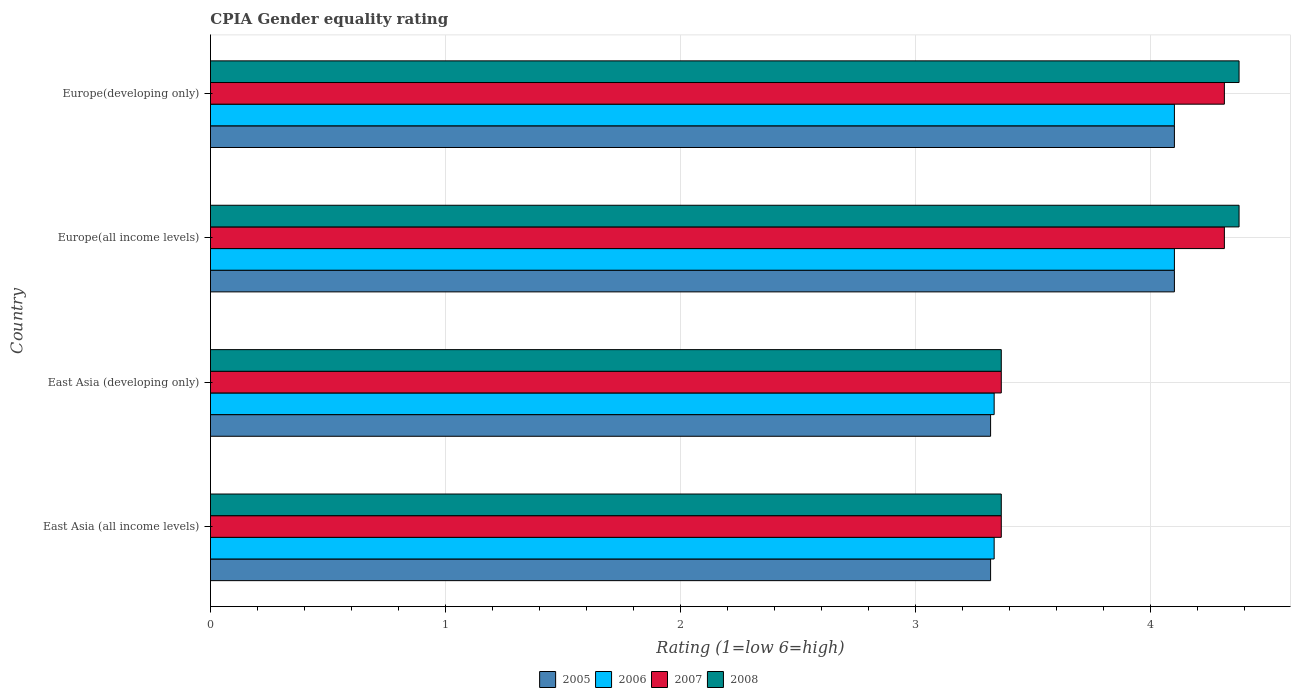How many different coloured bars are there?
Your response must be concise. 4. How many groups of bars are there?
Make the answer very short. 4. Are the number of bars on each tick of the Y-axis equal?
Make the answer very short. Yes. What is the label of the 4th group of bars from the top?
Your answer should be compact. East Asia (all income levels). What is the CPIA rating in 2007 in East Asia (developing only)?
Offer a very short reply. 3.36. Across all countries, what is the minimum CPIA rating in 2006?
Your answer should be very brief. 3.33. In which country was the CPIA rating in 2007 maximum?
Your answer should be very brief. Europe(all income levels). In which country was the CPIA rating in 2005 minimum?
Ensure brevity in your answer.  East Asia (all income levels). What is the total CPIA rating in 2008 in the graph?
Offer a terse response. 15.48. What is the difference between the CPIA rating in 2008 in East Asia (all income levels) and that in Europe(developing only)?
Provide a succinct answer. -1.01. What is the difference between the CPIA rating in 2007 in Europe(developing only) and the CPIA rating in 2005 in East Asia (developing only)?
Give a very brief answer. 0.99. What is the average CPIA rating in 2007 per country?
Your answer should be very brief. 3.84. What is the difference between the CPIA rating in 2007 and CPIA rating in 2005 in East Asia (developing only)?
Provide a succinct answer. 0.05. In how many countries, is the CPIA rating in 2008 greater than 0.8 ?
Provide a succinct answer. 4. Is the CPIA rating in 2008 in East Asia (all income levels) less than that in Europe(developing only)?
Provide a succinct answer. Yes. Is the difference between the CPIA rating in 2007 in East Asia (developing only) and Europe(all income levels) greater than the difference between the CPIA rating in 2005 in East Asia (developing only) and Europe(all income levels)?
Provide a short and direct response. No. What is the difference between the highest and the second highest CPIA rating in 2008?
Your response must be concise. 0. What is the difference between the highest and the lowest CPIA rating in 2006?
Offer a very short reply. 0.77. In how many countries, is the CPIA rating in 2005 greater than the average CPIA rating in 2005 taken over all countries?
Offer a very short reply. 2. Is the sum of the CPIA rating in 2007 in East Asia (developing only) and Europe(developing only) greater than the maximum CPIA rating in 2005 across all countries?
Your answer should be very brief. Yes. Is it the case that in every country, the sum of the CPIA rating in 2006 and CPIA rating in 2007 is greater than the sum of CPIA rating in 2005 and CPIA rating in 2008?
Ensure brevity in your answer.  No. What does the 2nd bar from the top in East Asia (all income levels) represents?
Provide a succinct answer. 2007. What does the 1st bar from the bottom in East Asia (all income levels) represents?
Give a very brief answer. 2005. How many bars are there?
Make the answer very short. 16. Are all the bars in the graph horizontal?
Provide a short and direct response. Yes. How many countries are there in the graph?
Offer a very short reply. 4. Does the graph contain any zero values?
Offer a very short reply. No. Does the graph contain grids?
Make the answer very short. Yes. How many legend labels are there?
Give a very brief answer. 4. How are the legend labels stacked?
Your response must be concise. Horizontal. What is the title of the graph?
Keep it short and to the point. CPIA Gender equality rating. Does "1985" appear as one of the legend labels in the graph?
Make the answer very short. No. What is the label or title of the X-axis?
Give a very brief answer. Rating (1=low 6=high). What is the Rating (1=low 6=high) of 2005 in East Asia (all income levels)?
Your answer should be compact. 3.32. What is the Rating (1=low 6=high) in 2006 in East Asia (all income levels)?
Provide a short and direct response. 3.33. What is the Rating (1=low 6=high) in 2007 in East Asia (all income levels)?
Your answer should be compact. 3.36. What is the Rating (1=low 6=high) in 2008 in East Asia (all income levels)?
Your answer should be very brief. 3.36. What is the Rating (1=low 6=high) in 2005 in East Asia (developing only)?
Offer a terse response. 3.32. What is the Rating (1=low 6=high) in 2006 in East Asia (developing only)?
Keep it short and to the point. 3.33. What is the Rating (1=low 6=high) in 2007 in East Asia (developing only)?
Keep it short and to the point. 3.36. What is the Rating (1=low 6=high) in 2008 in East Asia (developing only)?
Make the answer very short. 3.36. What is the Rating (1=low 6=high) in 2007 in Europe(all income levels)?
Your answer should be compact. 4.31. What is the Rating (1=low 6=high) in 2008 in Europe(all income levels)?
Your answer should be very brief. 4.38. What is the Rating (1=low 6=high) of 2007 in Europe(developing only)?
Provide a short and direct response. 4.31. What is the Rating (1=low 6=high) of 2008 in Europe(developing only)?
Keep it short and to the point. 4.38. Across all countries, what is the maximum Rating (1=low 6=high) of 2005?
Offer a very short reply. 4.1. Across all countries, what is the maximum Rating (1=low 6=high) of 2007?
Make the answer very short. 4.31. Across all countries, what is the maximum Rating (1=low 6=high) of 2008?
Provide a short and direct response. 4.38. Across all countries, what is the minimum Rating (1=low 6=high) of 2005?
Provide a short and direct response. 3.32. Across all countries, what is the minimum Rating (1=low 6=high) in 2006?
Make the answer very short. 3.33. Across all countries, what is the minimum Rating (1=low 6=high) of 2007?
Provide a succinct answer. 3.36. Across all countries, what is the minimum Rating (1=low 6=high) of 2008?
Keep it short and to the point. 3.36. What is the total Rating (1=low 6=high) of 2005 in the graph?
Offer a very short reply. 14.84. What is the total Rating (1=low 6=high) of 2006 in the graph?
Your response must be concise. 14.87. What is the total Rating (1=low 6=high) of 2007 in the graph?
Ensure brevity in your answer.  15.35. What is the total Rating (1=low 6=high) in 2008 in the graph?
Your answer should be compact. 15.48. What is the difference between the Rating (1=low 6=high) of 2005 in East Asia (all income levels) and that in East Asia (developing only)?
Ensure brevity in your answer.  0. What is the difference between the Rating (1=low 6=high) of 2006 in East Asia (all income levels) and that in East Asia (developing only)?
Offer a very short reply. 0. What is the difference between the Rating (1=low 6=high) in 2007 in East Asia (all income levels) and that in East Asia (developing only)?
Your answer should be compact. 0. What is the difference between the Rating (1=low 6=high) of 2008 in East Asia (all income levels) and that in East Asia (developing only)?
Your answer should be very brief. 0. What is the difference between the Rating (1=low 6=high) in 2005 in East Asia (all income levels) and that in Europe(all income levels)?
Provide a succinct answer. -0.78. What is the difference between the Rating (1=low 6=high) of 2006 in East Asia (all income levels) and that in Europe(all income levels)?
Your answer should be compact. -0.77. What is the difference between the Rating (1=low 6=high) in 2007 in East Asia (all income levels) and that in Europe(all income levels)?
Provide a short and direct response. -0.95. What is the difference between the Rating (1=low 6=high) of 2008 in East Asia (all income levels) and that in Europe(all income levels)?
Keep it short and to the point. -1.01. What is the difference between the Rating (1=low 6=high) in 2005 in East Asia (all income levels) and that in Europe(developing only)?
Keep it short and to the point. -0.78. What is the difference between the Rating (1=low 6=high) in 2006 in East Asia (all income levels) and that in Europe(developing only)?
Your response must be concise. -0.77. What is the difference between the Rating (1=low 6=high) of 2007 in East Asia (all income levels) and that in Europe(developing only)?
Make the answer very short. -0.95. What is the difference between the Rating (1=low 6=high) of 2008 in East Asia (all income levels) and that in Europe(developing only)?
Your answer should be compact. -1.01. What is the difference between the Rating (1=low 6=high) of 2005 in East Asia (developing only) and that in Europe(all income levels)?
Make the answer very short. -0.78. What is the difference between the Rating (1=low 6=high) of 2006 in East Asia (developing only) and that in Europe(all income levels)?
Your response must be concise. -0.77. What is the difference between the Rating (1=low 6=high) of 2007 in East Asia (developing only) and that in Europe(all income levels)?
Your answer should be compact. -0.95. What is the difference between the Rating (1=low 6=high) in 2008 in East Asia (developing only) and that in Europe(all income levels)?
Your answer should be very brief. -1.01. What is the difference between the Rating (1=low 6=high) in 2005 in East Asia (developing only) and that in Europe(developing only)?
Make the answer very short. -0.78. What is the difference between the Rating (1=low 6=high) in 2006 in East Asia (developing only) and that in Europe(developing only)?
Offer a terse response. -0.77. What is the difference between the Rating (1=low 6=high) in 2007 in East Asia (developing only) and that in Europe(developing only)?
Provide a succinct answer. -0.95. What is the difference between the Rating (1=low 6=high) of 2008 in East Asia (developing only) and that in Europe(developing only)?
Your answer should be compact. -1.01. What is the difference between the Rating (1=low 6=high) of 2005 in Europe(all income levels) and that in Europe(developing only)?
Keep it short and to the point. 0. What is the difference between the Rating (1=low 6=high) of 2006 in Europe(all income levels) and that in Europe(developing only)?
Offer a very short reply. 0. What is the difference between the Rating (1=low 6=high) in 2007 in Europe(all income levels) and that in Europe(developing only)?
Provide a short and direct response. 0. What is the difference between the Rating (1=low 6=high) of 2005 in East Asia (all income levels) and the Rating (1=low 6=high) of 2006 in East Asia (developing only)?
Your answer should be very brief. -0.02. What is the difference between the Rating (1=low 6=high) in 2005 in East Asia (all income levels) and the Rating (1=low 6=high) in 2007 in East Asia (developing only)?
Give a very brief answer. -0.05. What is the difference between the Rating (1=low 6=high) of 2005 in East Asia (all income levels) and the Rating (1=low 6=high) of 2008 in East Asia (developing only)?
Offer a terse response. -0.05. What is the difference between the Rating (1=low 6=high) of 2006 in East Asia (all income levels) and the Rating (1=low 6=high) of 2007 in East Asia (developing only)?
Give a very brief answer. -0.03. What is the difference between the Rating (1=low 6=high) in 2006 in East Asia (all income levels) and the Rating (1=low 6=high) in 2008 in East Asia (developing only)?
Provide a short and direct response. -0.03. What is the difference between the Rating (1=low 6=high) of 2005 in East Asia (all income levels) and the Rating (1=low 6=high) of 2006 in Europe(all income levels)?
Your answer should be compact. -0.78. What is the difference between the Rating (1=low 6=high) in 2005 in East Asia (all income levels) and the Rating (1=low 6=high) in 2007 in Europe(all income levels)?
Ensure brevity in your answer.  -0.99. What is the difference between the Rating (1=low 6=high) of 2005 in East Asia (all income levels) and the Rating (1=low 6=high) of 2008 in Europe(all income levels)?
Your response must be concise. -1.06. What is the difference between the Rating (1=low 6=high) in 2006 in East Asia (all income levels) and the Rating (1=low 6=high) in 2007 in Europe(all income levels)?
Offer a very short reply. -0.98. What is the difference between the Rating (1=low 6=high) of 2006 in East Asia (all income levels) and the Rating (1=low 6=high) of 2008 in Europe(all income levels)?
Your answer should be compact. -1.04. What is the difference between the Rating (1=low 6=high) in 2007 in East Asia (all income levels) and the Rating (1=low 6=high) in 2008 in Europe(all income levels)?
Provide a short and direct response. -1.01. What is the difference between the Rating (1=low 6=high) in 2005 in East Asia (all income levels) and the Rating (1=low 6=high) in 2006 in Europe(developing only)?
Ensure brevity in your answer.  -0.78. What is the difference between the Rating (1=low 6=high) of 2005 in East Asia (all income levels) and the Rating (1=low 6=high) of 2007 in Europe(developing only)?
Provide a succinct answer. -0.99. What is the difference between the Rating (1=low 6=high) in 2005 in East Asia (all income levels) and the Rating (1=low 6=high) in 2008 in Europe(developing only)?
Ensure brevity in your answer.  -1.06. What is the difference between the Rating (1=low 6=high) in 2006 in East Asia (all income levels) and the Rating (1=low 6=high) in 2007 in Europe(developing only)?
Keep it short and to the point. -0.98. What is the difference between the Rating (1=low 6=high) of 2006 in East Asia (all income levels) and the Rating (1=low 6=high) of 2008 in Europe(developing only)?
Offer a very short reply. -1.04. What is the difference between the Rating (1=low 6=high) of 2007 in East Asia (all income levels) and the Rating (1=low 6=high) of 2008 in Europe(developing only)?
Your answer should be compact. -1.01. What is the difference between the Rating (1=low 6=high) of 2005 in East Asia (developing only) and the Rating (1=low 6=high) of 2006 in Europe(all income levels)?
Ensure brevity in your answer.  -0.78. What is the difference between the Rating (1=low 6=high) of 2005 in East Asia (developing only) and the Rating (1=low 6=high) of 2007 in Europe(all income levels)?
Keep it short and to the point. -0.99. What is the difference between the Rating (1=low 6=high) of 2005 in East Asia (developing only) and the Rating (1=low 6=high) of 2008 in Europe(all income levels)?
Give a very brief answer. -1.06. What is the difference between the Rating (1=low 6=high) in 2006 in East Asia (developing only) and the Rating (1=low 6=high) in 2007 in Europe(all income levels)?
Give a very brief answer. -0.98. What is the difference between the Rating (1=low 6=high) of 2006 in East Asia (developing only) and the Rating (1=low 6=high) of 2008 in Europe(all income levels)?
Your answer should be very brief. -1.04. What is the difference between the Rating (1=low 6=high) of 2007 in East Asia (developing only) and the Rating (1=low 6=high) of 2008 in Europe(all income levels)?
Your answer should be very brief. -1.01. What is the difference between the Rating (1=low 6=high) of 2005 in East Asia (developing only) and the Rating (1=low 6=high) of 2006 in Europe(developing only)?
Your answer should be very brief. -0.78. What is the difference between the Rating (1=low 6=high) in 2005 in East Asia (developing only) and the Rating (1=low 6=high) in 2007 in Europe(developing only)?
Provide a succinct answer. -0.99. What is the difference between the Rating (1=low 6=high) in 2005 in East Asia (developing only) and the Rating (1=low 6=high) in 2008 in Europe(developing only)?
Ensure brevity in your answer.  -1.06. What is the difference between the Rating (1=low 6=high) of 2006 in East Asia (developing only) and the Rating (1=low 6=high) of 2007 in Europe(developing only)?
Your response must be concise. -0.98. What is the difference between the Rating (1=low 6=high) of 2006 in East Asia (developing only) and the Rating (1=low 6=high) of 2008 in Europe(developing only)?
Offer a very short reply. -1.04. What is the difference between the Rating (1=low 6=high) of 2007 in East Asia (developing only) and the Rating (1=low 6=high) of 2008 in Europe(developing only)?
Offer a very short reply. -1.01. What is the difference between the Rating (1=low 6=high) in 2005 in Europe(all income levels) and the Rating (1=low 6=high) in 2007 in Europe(developing only)?
Make the answer very short. -0.21. What is the difference between the Rating (1=low 6=high) of 2005 in Europe(all income levels) and the Rating (1=low 6=high) of 2008 in Europe(developing only)?
Make the answer very short. -0.28. What is the difference between the Rating (1=low 6=high) of 2006 in Europe(all income levels) and the Rating (1=low 6=high) of 2007 in Europe(developing only)?
Your answer should be compact. -0.21. What is the difference between the Rating (1=low 6=high) of 2006 in Europe(all income levels) and the Rating (1=low 6=high) of 2008 in Europe(developing only)?
Your answer should be very brief. -0.28. What is the difference between the Rating (1=low 6=high) of 2007 in Europe(all income levels) and the Rating (1=low 6=high) of 2008 in Europe(developing only)?
Provide a short and direct response. -0.06. What is the average Rating (1=low 6=high) of 2005 per country?
Offer a terse response. 3.71. What is the average Rating (1=low 6=high) of 2006 per country?
Keep it short and to the point. 3.72. What is the average Rating (1=low 6=high) of 2007 per country?
Give a very brief answer. 3.84. What is the average Rating (1=low 6=high) in 2008 per country?
Ensure brevity in your answer.  3.87. What is the difference between the Rating (1=low 6=high) of 2005 and Rating (1=low 6=high) of 2006 in East Asia (all income levels)?
Provide a succinct answer. -0.02. What is the difference between the Rating (1=low 6=high) in 2005 and Rating (1=low 6=high) in 2007 in East Asia (all income levels)?
Offer a very short reply. -0.05. What is the difference between the Rating (1=low 6=high) of 2005 and Rating (1=low 6=high) of 2008 in East Asia (all income levels)?
Your response must be concise. -0.05. What is the difference between the Rating (1=low 6=high) in 2006 and Rating (1=low 6=high) in 2007 in East Asia (all income levels)?
Your answer should be compact. -0.03. What is the difference between the Rating (1=low 6=high) in 2006 and Rating (1=low 6=high) in 2008 in East Asia (all income levels)?
Provide a short and direct response. -0.03. What is the difference between the Rating (1=low 6=high) of 2005 and Rating (1=low 6=high) of 2006 in East Asia (developing only)?
Keep it short and to the point. -0.02. What is the difference between the Rating (1=low 6=high) in 2005 and Rating (1=low 6=high) in 2007 in East Asia (developing only)?
Offer a terse response. -0.05. What is the difference between the Rating (1=low 6=high) of 2005 and Rating (1=low 6=high) of 2008 in East Asia (developing only)?
Provide a succinct answer. -0.05. What is the difference between the Rating (1=low 6=high) of 2006 and Rating (1=low 6=high) of 2007 in East Asia (developing only)?
Your response must be concise. -0.03. What is the difference between the Rating (1=low 6=high) in 2006 and Rating (1=low 6=high) in 2008 in East Asia (developing only)?
Your answer should be compact. -0.03. What is the difference between the Rating (1=low 6=high) of 2005 and Rating (1=low 6=high) of 2006 in Europe(all income levels)?
Your response must be concise. 0. What is the difference between the Rating (1=low 6=high) of 2005 and Rating (1=low 6=high) of 2007 in Europe(all income levels)?
Give a very brief answer. -0.21. What is the difference between the Rating (1=low 6=high) in 2005 and Rating (1=low 6=high) in 2008 in Europe(all income levels)?
Your answer should be very brief. -0.28. What is the difference between the Rating (1=low 6=high) in 2006 and Rating (1=low 6=high) in 2007 in Europe(all income levels)?
Make the answer very short. -0.21. What is the difference between the Rating (1=low 6=high) in 2006 and Rating (1=low 6=high) in 2008 in Europe(all income levels)?
Provide a succinct answer. -0.28. What is the difference between the Rating (1=low 6=high) of 2007 and Rating (1=low 6=high) of 2008 in Europe(all income levels)?
Your answer should be compact. -0.06. What is the difference between the Rating (1=low 6=high) in 2005 and Rating (1=low 6=high) in 2007 in Europe(developing only)?
Provide a succinct answer. -0.21. What is the difference between the Rating (1=low 6=high) in 2005 and Rating (1=low 6=high) in 2008 in Europe(developing only)?
Make the answer very short. -0.28. What is the difference between the Rating (1=low 6=high) in 2006 and Rating (1=low 6=high) in 2007 in Europe(developing only)?
Provide a short and direct response. -0.21. What is the difference between the Rating (1=low 6=high) in 2006 and Rating (1=low 6=high) in 2008 in Europe(developing only)?
Offer a terse response. -0.28. What is the difference between the Rating (1=low 6=high) of 2007 and Rating (1=low 6=high) of 2008 in Europe(developing only)?
Ensure brevity in your answer.  -0.06. What is the ratio of the Rating (1=low 6=high) of 2005 in East Asia (all income levels) to that in East Asia (developing only)?
Make the answer very short. 1. What is the ratio of the Rating (1=low 6=high) in 2006 in East Asia (all income levels) to that in East Asia (developing only)?
Your answer should be very brief. 1. What is the ratio of the Rating (1=low 6=high) of 2008 in East Asia (all income levels) to that in East Asia (developing only)?
Provide a succinct answer. 1. What is the ratio of the Rating (1=low 6=high) in 2005 in East Asia (all income levels) to that in Europe(all income levels)?
Provide a succinct answer. 0.81. What is the ratio of the Rating (1=low 6=high) of 2006 in East Asia (all income levels) to that in Europe(all income levels)?
Your response must be concise. 0.81. What is the ratio of the Rating (1=low 6=high) of 2007 in East Asia (all income levels) to that in Europe(all income levels)?
Your response must be concise. 0.78. What is the ratio of the Rating (1=low 6=high) in 2008 in East Asia (all income levels) to that in Europe(all income levels)?
Your response must be concise. 0.77. What is the ratio of the Rating (1=low 6=high) of 2005 in East Asia (all income levels) to that in Europe(developing only)?
Ensure brevity in your answer.  0.81. What is the ratio of the Rating (1=low 6=high) of 2006 in East Asia (all income levels) to that in Europe(developing only)?
Make the answer very short. 0.81. What is the ratio of the Rating (1=low 6=high) of 2007 in East Asia (all income levels) to that in Europe(developing only)?
Your response must be concise. 0.78. What is the ratio of the Rating (1=low 6=high) in 2008 in East Asia (all income levels) to that in Europe(developing only)?
Give a very brief answer. 0.77. What is the ratio of the Rating (1=low 6=high) of 2005 in East Asia (developing only) to that in Europe(all income levels)?
Your response must be concise. 0.81. What is the ratio of the Rating (1=low 6=high) in 2006 in East Asia (developing only) to that in Europe(all income levels)?
Offer a terse response. 0.81. What is the ratio of the Rating (1=low 6=high) of 2007 in East Asia (developing only) to that in Europe(all income levels)?
Your answer should be very brief. 0.78. What is the ratio of the Rating (1=low 6=high) in 2008 in East Asia (developing only) to that in Europe(all income levels)?
Keep it short and to the point. 0.77. What is the ratio of the Rating (1=low 6=high) of 2005 in East Asia (developing only) to that in Europe(developing only)?
Offer a very short reply. 0.81. What is the ratio of the Rating (1=low 6=high) in 2006 in East Asia (developing only) to that in Europe(developing only)?
Provide a succinct answer. 0.81. What is the ratio of the Rating (1=low 6=high) of 2007 in East Asia (developing only) to that in Europe(developing only)?
Ensure brevity in your answer.  0.78. What is the ratio of the Rating (1=low 6=high) in 2008 in East Asia (developing only) to that in Europe(developing only)?
Your response must be concise. 0.77. What is the ratio of the Rating (1=low 6=high) of 2007 in Europe(all income levels) to that in Europe(developing only)?
Offer a very short reply. 1. What is the difference between the highest and the second highest Rating (1=low 6=high) of 2005?
Your answer should be compact. 0. What is the difference between the highest and the second highest Rating (1=low 6=high) of 2008?
Give a very brief answer. 0. What is the difference between the highest and the lowest Rating (1=low 6=high) of 2005?
Make the answer very short. 0.78. What is the difference between the highest and the lowest Rating (1=low 6=high) in 2006?
Provide a succinct answer. 0.77. What is the difference between the highest and the lowest Rating (1=low 6=high) in 2007?
Your answer should be compact. 0.95. What is the difference between the highest and the lowest Rating (1=low 6=high) in 2008?
Offer a very short reply. 1.01. 